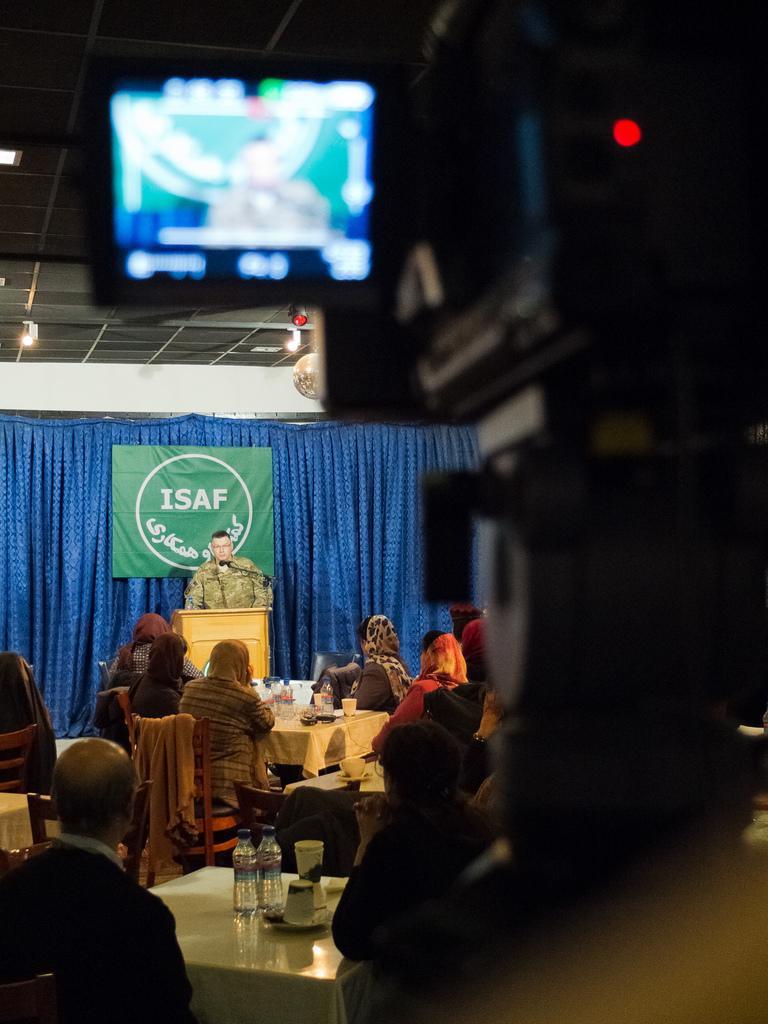Can you describe this image briefly? There is a camera which displays a picture on it in the right corner and there are few people sitting in chairs and there is a table in front of them which has water bottles and some other objects on it and there is a person standing and speaking in front of a mic in the background. 